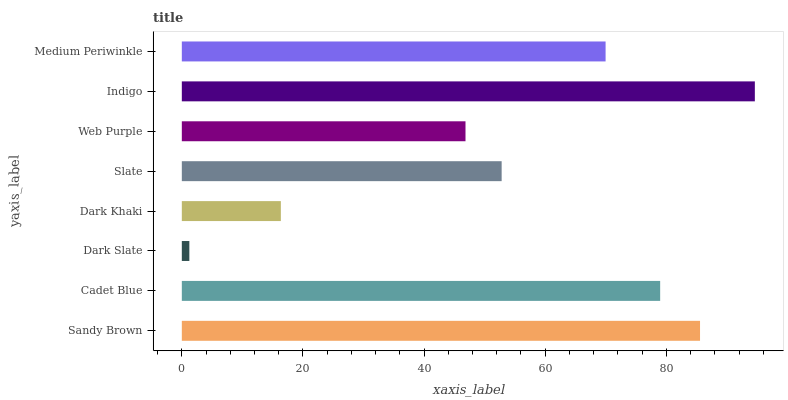Is Dark Slate the minimum?
Answer yes or no. Yes. Is Indigo the maximum?
Answer yes or no. Yes. Is Cadet Blue the minimum?
Answer yes or no. No. Is Cadet Blue the maximum?
Answer yes or no. No. Is Sandy Brown greater than Cadet Blue?
Answer yes or no. Yes. Is Cadet Blue less than Sandy Brown?
Answer yes or no. Yes. Is Cadet Blue greater than Sandy Brown?
Answer yes or no. No. Is Sandy Brown less than Cadet Blue?
Answer yes or no. No. Is Medium Periwinkle the high median?
Answer yes or no. Yes. Is Slate the low median?
Answer yes or no. Yes. Is Dark Slate the high median?
Answer yes or no. No. Is Indigo the low median?
Answer yes or no. No. 